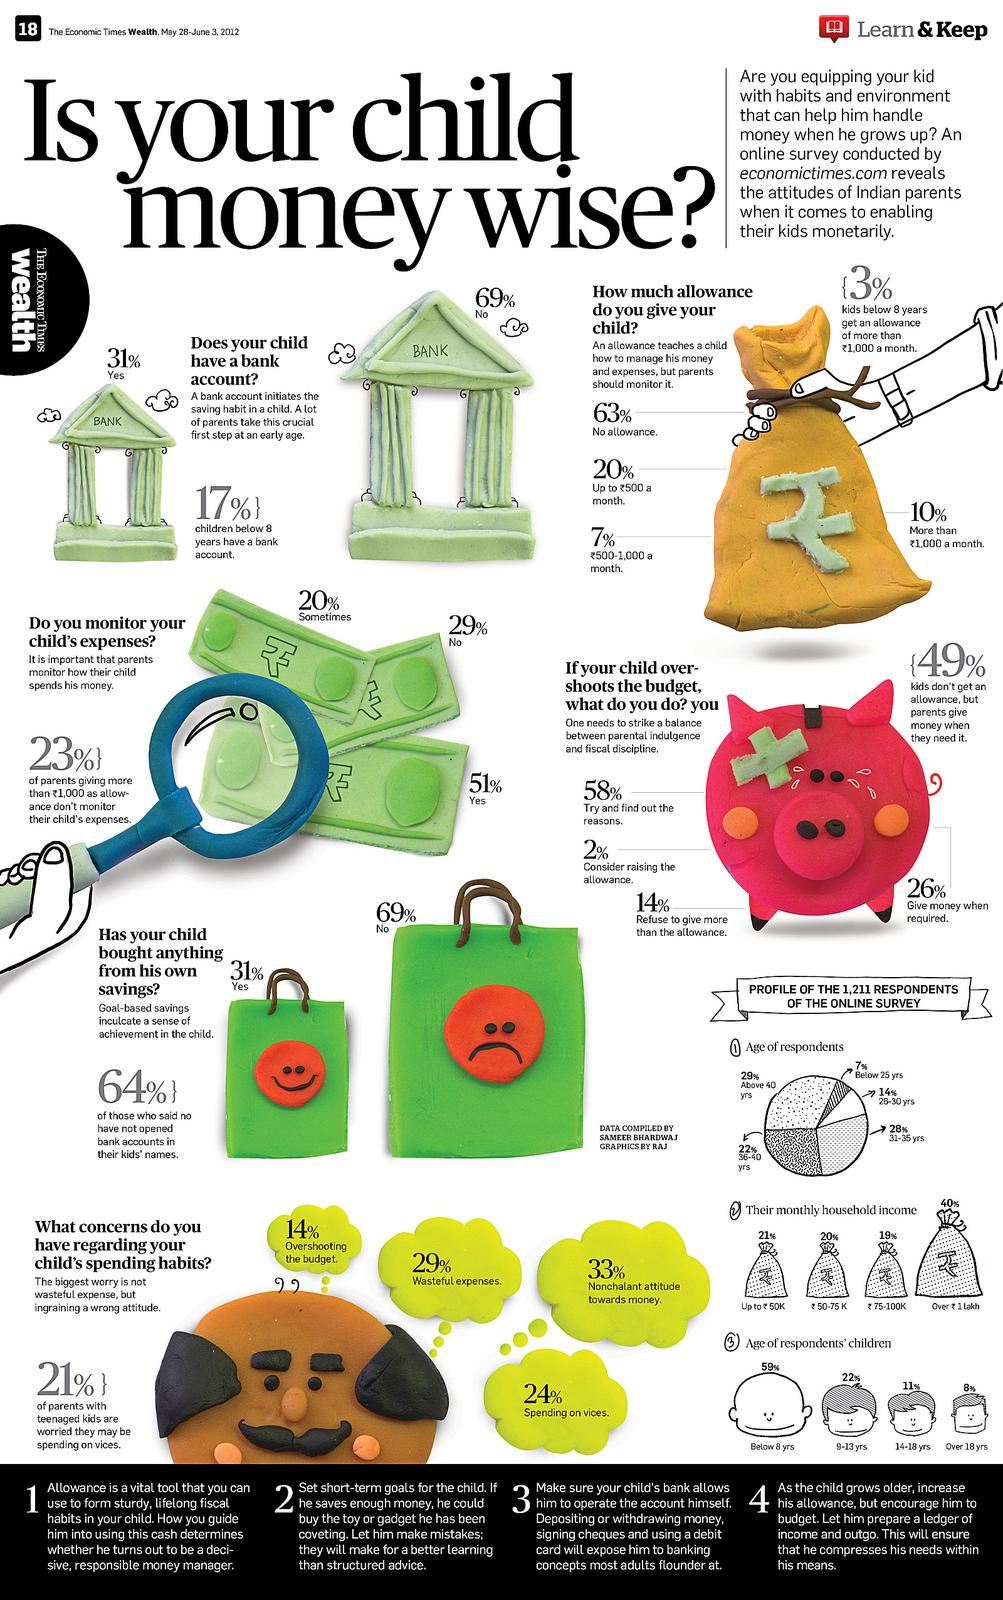Give some essential details in this illustration. Sixth-grade students who do not receive an allowance at all constitute approximately 63% of the sample population. According to data, only 17% of children below the age of eight have a bank account. This suggests that a significant portion of young children are not taking advantage of the financial services that banks offer. It is important to encourage parents and caregivers to open bank accounts for their children to help them develop healthy financial habits and prepare for their future financial needs. 